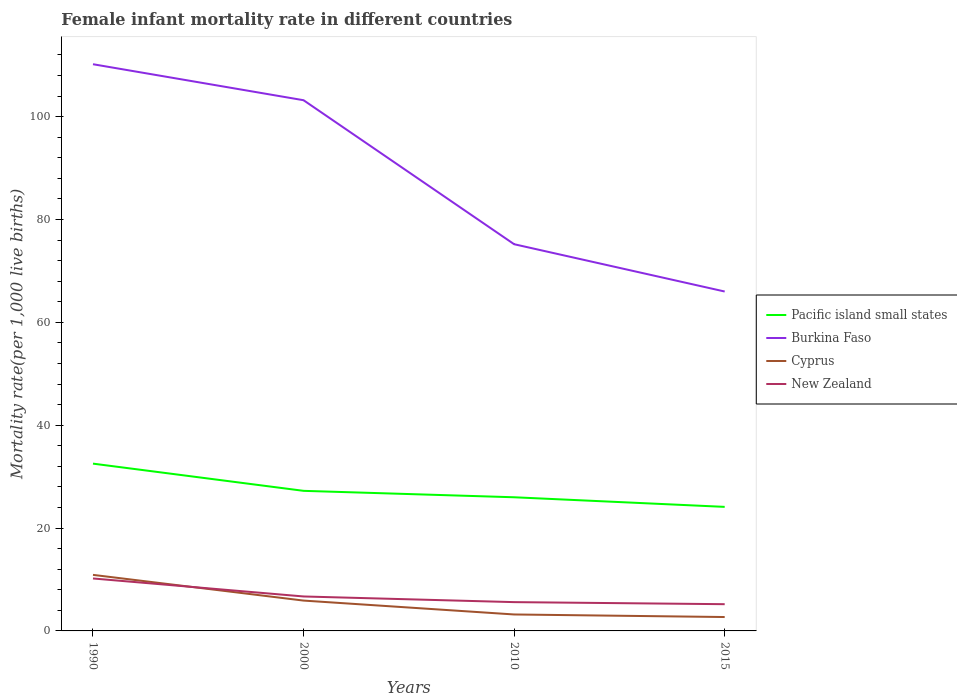How many different coloured lines are there?
Give a very brief answer. 4. In which year was the female infant mortality rate in Burkina Faso maximum?
Your answer should be compact. 2015. What is the total female infant mortality rate in Burkina Faso in the graph?
Provide a succinct answer. 35. What is the difference between the highest and the second highest female infant mortality rate in New Zealand?
Provide a short and direct response. 5. What is the difference between the highest and the lowest female infant mortality rate in Cyprus?
Make the answer very short. 2. Is the female infant mortality rate in Burkina Faso strictly greater than the female infant mortality rate in Pacific island small states over the years?
Your answer should be very brief. No. How many lines are there?
Provide a short and direct response. 4. How many years are there in the graph?
Provide a succinct answer. 4. Does the graph contain any zero values?
Make the answer very short. No. Does the graph contain grids?
Your answer should be compact. No. Where does the legend appear in the graph?
Ensure brevity in your answer.  Center right. How many legend labels are there?
Your answer should be compact. 4. What is the title of the graph?
Provide a short and direct response. Female infant mortality rate in different countries. What is the label or title of the Y-axis?
Offer a very short reply. Mortality rate(per 1,0 live births). What is the Mortality rate(per 1,000 live births) of Pacific island small states in 1990?
Your answer should be compact. 32.53. What is the Mortality rate(per 1,000 live births) of Burkina Faso in 1990?
Your answer should be compact. 110.2. What is the Mortality rate(per 1,000 live births) in Cyprus in 1990?
Your response must be concise. 10.9. What is the Mortality rate(per 1,000 live births) in New Zealand in 1990?
Keep it short and to the point. 10.2. What is the Mortality rate(per 1,000 live births) of Pacific island small states in 2000?
Offer a terse response. 27.24. What is the Mortality rate(per 1,000 live births) in Burkina Faso in 2000?
Keep it short and to the point. 103.2. What is the Mortality rate(per 1,000 live births) of Cyprus in 2000?
Give a very brief answer. 5.9. What is the Mortality rate(per 1,000 live births) in New Zealand in 2000?
Keep it short and to the point. 6.7. What is the Mortality rate(per 1,000 live births) of Pacific island small states in 2010?
Your answer should be very brief. 25.99. What is the Mortality rate(per 1,000 live births) of Burkina Faso in 2010?
Keep it short and to the point. 75.2. What is the Mortality rate(per 1,000 live births) in Cyprus in 2010?
Offer a very short reply. 3.2. What is the Mortality rate(per 1,000 live births) in Pacific island small states in 2015?
Your response must be concise. 24.12. Across all years, what is the maximum Mortality rate(per 1,000 live births) of Pacific island small states?
Make the answer very short. 32.53. Across all years, what is the maximum Mortality rate(per 1,000 live births) in Burkina Faso?
Keep it short and to the point. 110.2. Across all years, what is the maximum Mortality rate(per 1,000 live births) of New Zealand?
Offer a very short reply. 10.2. Across all years, what is the minimum Mortality rate(per 1,000 live births) in Pacific island small states?
Keep it short and to the point. 24.12. Across all years, what is the minimum Mortality rate(per 1,000 live births) of Burkina Faso?
Offer a very short reply. 66. Across all years, what is the minimum Mortality rate(per 1,000 live births) of Cyprus?
Make the answer very short. 2.7. What is the total Mortality rate(per 1,000 live births) in Pacific island small states in the graph?
Ensure brevity in your answer.  109.88. What is the total Mortality rate(per 1,000 live births) of Burkina Faso in the graph?
Your answer should be very brief. 354.6. What is the total Mortality rate(per 1,000 live births) in Cyprus in the graph?
Your answer should be very brief. 22.7. What is the total Mortality rate(per 1,000 live births) in New Zealand in the graph?
Keep it short and to the point. 27.7. What is the difference between the Mortality rate(per 1,000 live births) in Pacific island small states in 1990 and that in 2000?
Provide a succinct answer. 5.29. What is the difference between the Mortality rate(per 1,000 live births) of Pacific island small states in 1990 and that in 2010?
Keep it short and to the point. 6.54. What is the difference between the Mortality rate(per 1,000 live births) in Cyprus in 1990 and that in 2010?
Provide a succinct answer. 7.7. What is the difference between the Mortality rate(per 1,000 live births) in New Zealand in 1990 and that in 2010?
Give a very brief answer. 4.6. What is the difference between the Mortality rate(per 1,000 live births) in Pacific island small states in 1990 and that in 2015?
Your answer should be compact. 8.41. What is the difference between the Mortality rate(per 1,000 live births) in Burkina Faso in 1990 and that in 2015?
Keep it short and to the point. 44.2. What is the difference between the Mortality rate(per 1,000 live births) in Pacific island small states in 2000 and that in 2010?
Offer a terse response. 1.25. What is the difference between the Mortality rate(per 1,000 live births) of Burkina Faso in 2000 and that in 2010?
Provide a succinct answer. 28. What is the difference between the Mortality rate(per 1,000 live births) of Pacific island small states in 2000 and that in 2015?
Give a very brief answer. 3.12. What is the difference between the Mortality rate(per 1,000 live births) in Burkina Faso in 2000 and that in 2015?
Provide a succinct answer. 37.2. What is the difference between the Mortality rate(per 1,000 live births) of Cyprus in 2000 and that in 2015?
Offer a very short reply. 3.2. What is the difference between the Mortality rate(per 1,000 live births) of New Zealand in 2000 and that in 2015?
Your answer should be compact. 1.5. What is the difference between the Mortality rate(per 1,000 live births) of Pacific island small states in 2010 and that in 2015?
Offer a terse response. 1.87. What is the difference between the Mortality rate(per 1,000 live births) of Burkina Faso in 2010 and that in 2015?
Provide a succinct answer. 9.2. What is the difference between the Mortality rate(per 1,000 live births) of Cyprus in 2010 and that in 2015?
Your answer should be compact. 0.5. What is the difference between the Mortality rate(per 1,000 live births) of Pacific island small states in 1990 and the Mortality rate(per 1,000 live births) of Burkina Faso in 2000?
Make the answer very short. -70.67. What is the difference between the Mortality rate(per 1,000 live births) of Pacific island small states in 1990 and the Mortality rate(per 1,000 live births) of Cyprus in 2000?
Your answer should be very brief. 26.63. What is the difference between the Mortality rate(per 1,000 live births) of Pacific island small states in 1990 and the Mortality rate(per 1,000 live births) of New Zealand in 2000?
Your answer should be compact. 25.83. What is the difference between the Mortality rate(per 1,000 live births) in Burkina Faso in 1990 and the Mortality rate(per 1,000 live births) in Cyprus in 2000?
Provide a succinct answer. 104.3. What is the difference between the Mortality rate(per 1,000 live births) in Burkina Faso in 1990 and the Mortality rate(per 1,000 live births) in New Zealand in 2000?
Your response must be concise. 103.5. What is the difference between the Mortality rate(per 1,000 live births) in Pacific island small states in 1990 and the Mortality rate(per 1,000 live births) in Burkina Faso in 2010?
Give a very brief answer. -42.67. What is the difference between the Mortality rate(per 1,000 live births) in Pacific island small states in 1990 and the Mortality rate(per 1,000 live births) in Cyprus in 2010?
Provide a short and direct response. 29.33. What is the difference between the Mortality rate(per 1,000 live births) of Pacific island small states in 1990 and the Mortality rate(per 1,000 live births) of New Zealand in 2010?
Your answer should be very brief. 26.93. What is the difference between the Mortality rate(per 1,000 live births) in Burkina Faso in 1990 and the Mortality rate(per 1,000 live births) in Cyprus in 2010?
Your answer should be compact. 107. What is the difference between the Mortality rate(per 1,000 live births) of Burkina Faso in 1990 and the Mortality rate(per 1,000 live births) of New Zealand in 2010?
Your response must be concise. 104.6. What is the difference between the Mortality rate(per 1,000 live births) of Pacific island small states in 1990 and the Mortality rate(per 1,000 live births) of Burkina Faso in 2015?
Your response must be concise. -33.47. What is the difference between the Mortality rate(per 1,000 live births) in Pacific island small states in 1990 and the Mortality rate(per 1,000 live births) in Cyprus in 2015?
Give a very brief answer. 29.83. What is the difference between the Mortality rate(per 1,000 live births) of Pacific island small states in 1990 and the Mortality rate(per 1,000 live births) of New Zealand in 2015?
Provide a short and direct response. 27.33. What is the difference between the Mortality rate(per 1,000 live births) in Burkina Faso in 1990 and the Mortality rate(per 1,000 live births) in Cyprus in 2015?
Your answer should be compact. 107.5. What is the difference between the Mortality rate(per 1,000 live births) in Burkina Faso in 1990 and the Mortality rate(per 1,000 live births) in New Zealand in 2015?
Your answer should be compact. 105. What is the difference between the Mortality rate(per 1,000 live births) of Cyprus in 1990 and the Mortality rate(per 1,000 live births) of New Zealand in 2015?
Give a very brief answer. 5.7. What is the difference between the Mortality rate(per 1,000 live births) in Pacific island small states in 2000 and the Mortality rate(per 1,000 live births) in Burkina Faso in 2010?
Give a very brief answer. -47.96. What is the difference between the Mortality rate(per 1,000 live births) in Pacific island small states in 2000 and the Mortality rate(per 1,000 live births) in Cyprus in 2010?
Give a very brief answer. 24.04. What is the difference between the Mortality rate(per 1,000 live births) in Pacific island small states in 2000 and the Mortality rate(per 1,000 live births) in New Zealand in 2010?
Keep it short and to the point. 21.64. What is the difference between the Mortality rate(per 1,000 live births) of Burkina Faso in 2000 and the Mortality rate(per 1,000 live births) of New Zealand in 2010?
Provide a short and direct response. 97.6. What is the difference between the Mortality rate(per 1,000 live births) in Cyprus in 2000 and the Mortality rate(per 1,000 live births) in New Zealand in 2010?
Provide a short and direct response. 0.3. What is the difference between the Mortality rate(per 1,000 live births) in Pacific island small states in 2000 and the Mortality rate(per 1,000 live births) in Burkina Faso in 2015?
Your answer should be compact. -38.76. What is the difference between the Mortality rate(per 1,000 live births) of Pacific island small states in 2000 and the Mortality rate(per 1,000 live births) of Cyprus in 2015?
Offer a terse response. 24.54. What is the difference between the Mortality rate(per 1,000 live births) of Pacific island small states in 2000 and the Mortality rate(per 1,000 live births) of New Zealand in 2015?
Provide a short and direct response. 22.04. What is the difference between the Mortality rate(per 1,000 live births) in Burkina Faso in 2000 and the Mortality rate(per 1,000 live births) in Cyprus in 2015?
Give a very brief answer. 100.5. What is the difference between the Mortality rate(per 1,000 live births) in Pacific island small states in 2010 and the Mortality rate(per 1,000 live births) in Burkina Faso in 2015?
Make the answer very short. -40.01. What is the difference between the Mortality rate(per 1,000 live births) of Pacific island small states in 2010 and the Mortality rate(per 1,000 live births) of Cyprus in 2015?
Offer a very short reply. 23.29. What is the difference between the Mortality rate(per 1,000 live births) of Pacific island small states in 2010 and the Mortality rate(per 1,000 live births) of New Zealand in 2015?
Provide a short and direct response. 20.79. What is the difference between the Mortality rate(per 1,000 live births) in Burkina Faso in 2010 and the Mortality rate(per 1,000 live births) in Cyprus in 2015?
Give a very brief answer. 72.5. What is the difference between the Mortality rate(per 1,000 live births) of Burkina Faso in 2010 and the Mortality rate(per 1,000 live births) of New Zealand in 2015?
Provide a succinct answer. 70. What is the average Mortality rate(per 1,000 live births) in Pacific island small states per year?
Provide a succinct answer. 27.47. What is the average Mortality rate(per 1,000 live births) in Burkina Faso per year?
Your response must be concise. 88.65. What is the average Mortality rate(per 1,000 live births) in Cyprus per year?
Keep it short and to the point. 5.67. What is the average Mortality rate(per 1,000 live births) of New Zealand per year?
Ensure brevity in your answer.  6.92. In the year 1990, what is the difference between the Mortality rate(per 1,000 live births) of Pacific island small states and Mortality rate(per 1,000 live births) of Burkina Faso?
Your answer should be very brief. -77.67. In the year 1990, what is the difference between the Mortality rate(per 1,000 live births) in Pacific island small states and Mortality rate(per 1,000 live births) in Cyprus?
Give a very brief answer. 21.63. In the year 1990, what is the difference between the Mortality rate(per 1,000 live births) in Pacific island small states and Mortality rate(per 1,000 live births) in New Zealand?
Provide a short and direct response. 22.33. In the year 1990, what is the difference between the Mortality rate(per 1,000 live births) in Burkina Faso and Mortality rate(per 1,000 live births) in Cyprus?
Make the answer very short. 99.3. In the year 2000, what is the difference between the Mortality rate(per 1,000 live births) in Pacific island small states and Mortality rate(per 1,000 live births) in Burkina Faso?
Your answer should be very brief. -75.96. In the year 2000, what is the difference between the Mortality rate(per 1,000 live births) in Pacific island small states and Mortality rate(per 1,000 live births) in Cyprus?
Keep it short and to the point. 21.34. In the year 2000, what is the difference between the Mortality rate(per 1,000 live births) in Pacific island small states and Mortality rate(per 1,000 live births) in New Zealand?
Keep it short and to the point. 20.54. In the year 2000, what is the difference between the Mortality rate(per 1,000 live births) of Burkina Faso and Mortality rate(per 1,000 live births) of Cyprus?
Ensure brevity in your answer.  97.3. In the year 2000, what is the difference between the Mortality rate(per 1,000 live births) of Burkina Faso and Mortality rate(per 1,000 live births) of New Zealand?
Provide a succinct answer. 96.5. In the year 2000, what is the difference between the Mortality rate(per 1,000 live births) in Cyprus and Mortality rate(per 1,000 live births) in New Zealand?
Ensure brevity in your answer.  -0.8. In the year 2010, what is the difference between the Mortality rate(per 1,000 live births) in Pacific island small states and Mortality rate(per 1,000 live births) in Burkina Faso?
Your answer should be compact. -49.21. In the year 2010, what is the difference between the Mortality rate(per 1,000 live births) of Pacific island small states and Mortality rate(per 1,000 live births) of Cyprus?
Your response must be concise. 22.79. In the year 2010, what is the difference between the Mortality rate(per 1,000 live births) of Pacific island small states and Mortality rate(per 1,000 live births) of New Zealand?
Offer a terse response. 20.39. In the year 2010, what is the difference between the Mortality rate(per 1,000 live births) in Burkina Faso and Mortality rate(per 1,000 live births) in Cyprus?
Ensure brevity in your answer.  72. In the year 2010, what is the difference between the Mortality rate(per 1,000 live births) in Burkina Faso and Mortality rate(per 1,000 live births) in New Zealand?
Give a very brief answer. 69.6. In the year 2015, what is the difference between the Mortality rate(per 1,000 live births) in Pacific island small states and Mortality rate(per 1,000 live births) in Burkina Faso?
Keep it short and to the point. -41.88. In the year 2015, what is the difference between the Mortality rate(per 1,000 live births) in Pacific island small states and Mortality rate(per 1,000 live births) in Cyprus?
Your response must be concise. 21.42. In the year 2015, what is the difference between the Mortality rate(per 1,000 live births) in Pacific island small states and Mortality rate(per 1,000 live births) in New Zealand?
Provide a short and direct response. 18.92. In the year 2015, what is the difference between the Mortality rate(per 1,000 live births) in Burkina Faso and Mortality rate(per 1,000 live births) in Cyprus?
Offer a very short reply. 63.3. In the year 2015, what is the difference between the Mortality rate(per 1,000 live births) in Burkina Faso and Mortality rate(per 1,000 live births) in New Zealand?
Your answer should be very brief. 60.8. What is the ratio of the Mortality rate(per 1,000 live births) in Pacific island small states in 1990 to that in 2000?
Your answer should be compact. 1.19. What is the ratio of the Mortality rate(per 1,000 live births) in Burkina Faso in 1990 to that in 2000?
Your answer should be very brief. 1.07. What is the ratio of the Mortality rate(per 1,000 live births) of Cyprus in 1990 to that in 2000?
Provide a short and direct response. 1.85. What is the ratio of the Mortality rate(per 1,000 live births) in New Zealand in 1990 to that in 2000?
Your response must be concise. 1.52. What is the ratio of the Mortality rate(per 1,000 live births) of Pacific island small states in 1990 to that in 2010?
Provide a succinct answer. 1.25. What is the ratio of the Mortality rate(per 1,000 live births) of Burkina Faso in 1990 to that in 2010?
Give a very brief answer. 1.47. What is the ratio of the Mortality rate(per 1,000 live births) of Cyprus in 1990 to that in 2010?
Offer a terse response. 3.41. What is the ratio of the Mortality rate(per 1,000 live births) in New Zealand in 1990 to that in 2010?
Provide a short and direct response. 1.82. What is the ratio of the Mortality rate(per 1,000 live births) of Pacific island small states in 1990 to that in 2015?
Offer a very short reply. 1.35. What is the ratio of the Mortality rate(per 1,000 live births) in Burkina Faso in 1990 to that in 2015?
Your answer should be compact. 1.67. What is the ratio of the Mortality rate(per 1,000 live births) of Cyprus in 1990 to that in 2015?
Keep it short and to the point. 4.04. What is the ratio of the Mortality rate(per 1,000 live births) in New Zealand in 1990 to that in 2015?
Your answer should be very brief. 1.96. What is the ratio of the Mortality rate(per 1,000 live births) in Pacific island small states in 2000 to that in 2010?
Offer a very short reply. 1.05. What is the ratio of the Mortality rate(per 1,000 live births) in Burkina Faso in 2000 to that in 2010?
Give a very brief answer. 1.37. What is the ratio of the Mortality rate(per 1,000 live births) of Cyprus in 2000 to that in 2010?
Your answer should be very brief. 1.84. What is the ratio of the Mortality rate(per 1,000 live births) in New Zealand in 2000 to that in 2010?
Your answer should be compact. 1.2. What is the ratio of the Mortality rate(per 1,000 live births) of Pacific island small states in 2000 to that in 2015?
Make the answer very short. 1.13. What is the ratio of the Mortality rate(per 1,000 live births) in Burkina Faso in 2000 to that in 2015?
Make the answer very short. 1.56. What is the ratio of the Mortality rate(per 1,000 live births) in Cyprus in 2000 to that in 2015?
Provide a succinct answer. 2.19. What is the ratio of the Mortality rate(per 1,000 live births) of New Zealand in 2000 to that in 2015?
Provide a short and direct response. 1.29. What is the ratio of the Mortality rate(per 1,000 live births) of Pacific island small states in 2010 to that in 2015?
Your answer should be very brief. 1.08. What is the ratio of the Mortality rate(per 1,000 live births) of Burkina Faso in 2010 to that in 2015?
Make the answer very short. 1.14. What is the ratio of the Mortality rate(per 1,000 live births) in Cyprus in 2010 to that in 2015?
Your response must be concise. 1.19. What is the difference between the highest and the second highest Mortality rate(per 1,000 live births) in Pacific island small states?
Provide a short and direct response. 5.29. What is the difference between the highest and the second highest Mortality rate(per 1,000 live births) in Burkina Faso?
Ensure brevity in your answer.  7. What is the difference between the highest and the second highest Mortality rate(per 1,000 live births) of Cyprus?
Your answer should be compact. 5. What is the difference between the highest and the lowest Mortality rate(per 1,000 live births) in Pacific island small states?
Offer a terse response. 8.41. What is the difference between the highest and the lowest Mortality rate(per 1,000 live births) in Burkina Faso?
Your answer should be very brief. 44.2. What is the difference between the highest and the lowest Mortality rate(per 1,000 live births) of New Zealand?
Your response must be concise. 5. 